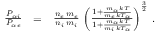<formula> <loc_0><loc_0><loc_500><loc_500>\begin{array} { r l r } { \frac { P _ { \alpha i } } { P _ { \alpha e } } } & { = } & { \frac { n _ { e } \, m _ { e } } { n _ { i } \, m _ { i } } \, \left ( \frac { 1 + \frac { m _ { \alpha } \, k T } { m _ { e } \, k T _ { \alpha } } } { 1 + \frac { m _ { \alpha } \, k T } { m _ { i } \, k T _ { \alpha } } } \right ) ^ { \frac { 3 } { 2 } } \, . } \end{array}</formula> 